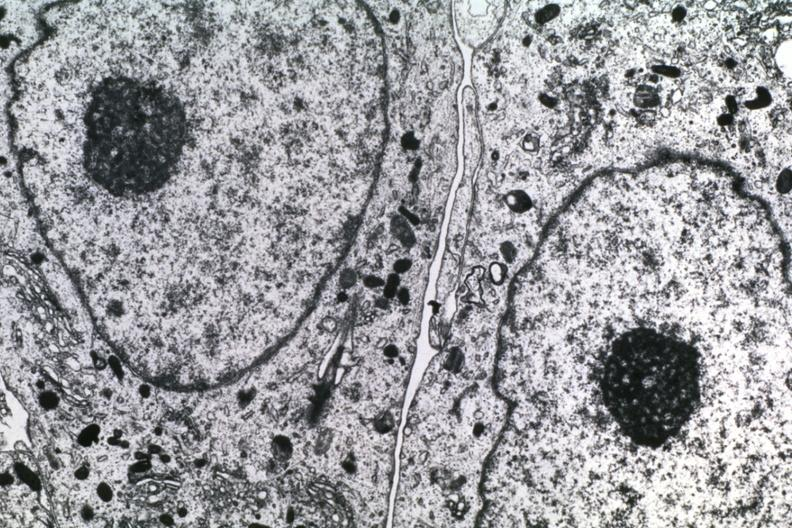does photo show dr garcia tumors 58?
Answer the question using a single word or phrase. No 